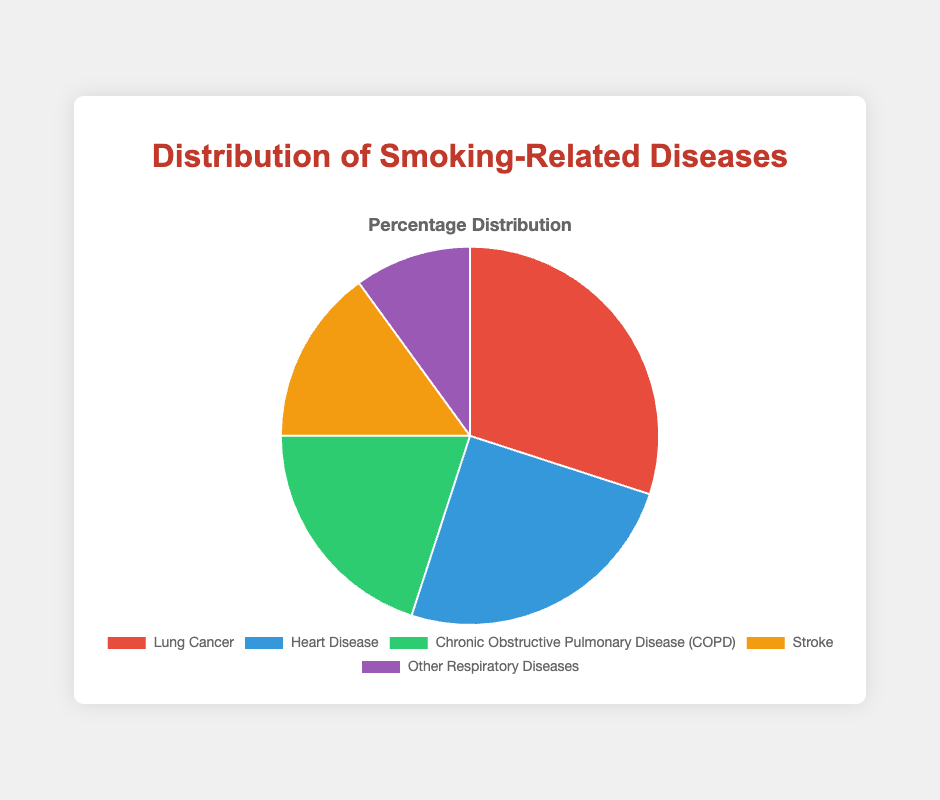What percentage of the total distribution is accounted for by Lung Cancer and Heart Disease combined? To find the percentage of Lung Cancer and Heart Disease combined, sum their individual percentages and then divide by the total percentage (which is 100%). The sum is 30% + 25% = 55%.
Answer: 55% Which smoking-related disease has the smallest percentage share in the pie chart? By visually inspecting the pie chart or referring to the data, it's clear that "Other Respiratory Diseases" has the smallest slice, which is 10%.
Answer: Other Respiratory Diseases Which disease is represented by the green slice in the pie chart? By looking at the figure and matching the color to the labels, the green slice corresponds to "Chronic Obstructive Pulmonary Disease (COPD)" which is 20%.
Answer: Chronic Obstructive Pulmonary Disease (COPD) How much larger is the percentage of Lung Cancer than the percentage of Stroke? Find the difference between the percentages of Lung Cancer and Stroke. Lung Cancer has 30%, and Stroke has 15%. The difference is 30% - 15% = 15%.
Answer: 15% If you combine Heart Disease, Stroke, and Other Respiratory Diseases, what is their total percentage share? Sum the percentages of Heart Disease, Stroke, and Other Respiratory Diseases: 25% + 15% + 10% = 50%.
Answer: 50% Which two diseases together make up exactly half of the total distribution? Check different combinations of diseases to see which sum exactly to 50%. Heart Disease and Chronic Obstructive Pulmonary Disease (COPD) sum to 25% + 20% = 45%, whereas Chronic Obstructive Pulmonary Disease (COPD) and Stroke sum to 20% + 15% = 35%, and so on. The correct combination is actually the trio of Heart Disease, Stroke, and Other Respiratory Diseases: 25% + 15% + 10% = 50%.
Answer: Heart Disease, Stroke, and Other Respiratory Diseases Which disease associated with smoking has the second highest percentage? Lung Cancer has the highest percentage with 30%. The next highest percentage is Heart Disease with 25%.
Answer: Heart Disease What's the difference between the percentage shares of Chronic Obstructive Pulmonary Disease (COPD) and Other Respiratory Diseases? Subtract the percentage of Other Respiratory Diseases from COPD. COPD is 20% and Other Respiratory Diseases are 10%. So, 20% - 10% = 10%.
Answer: 10% 